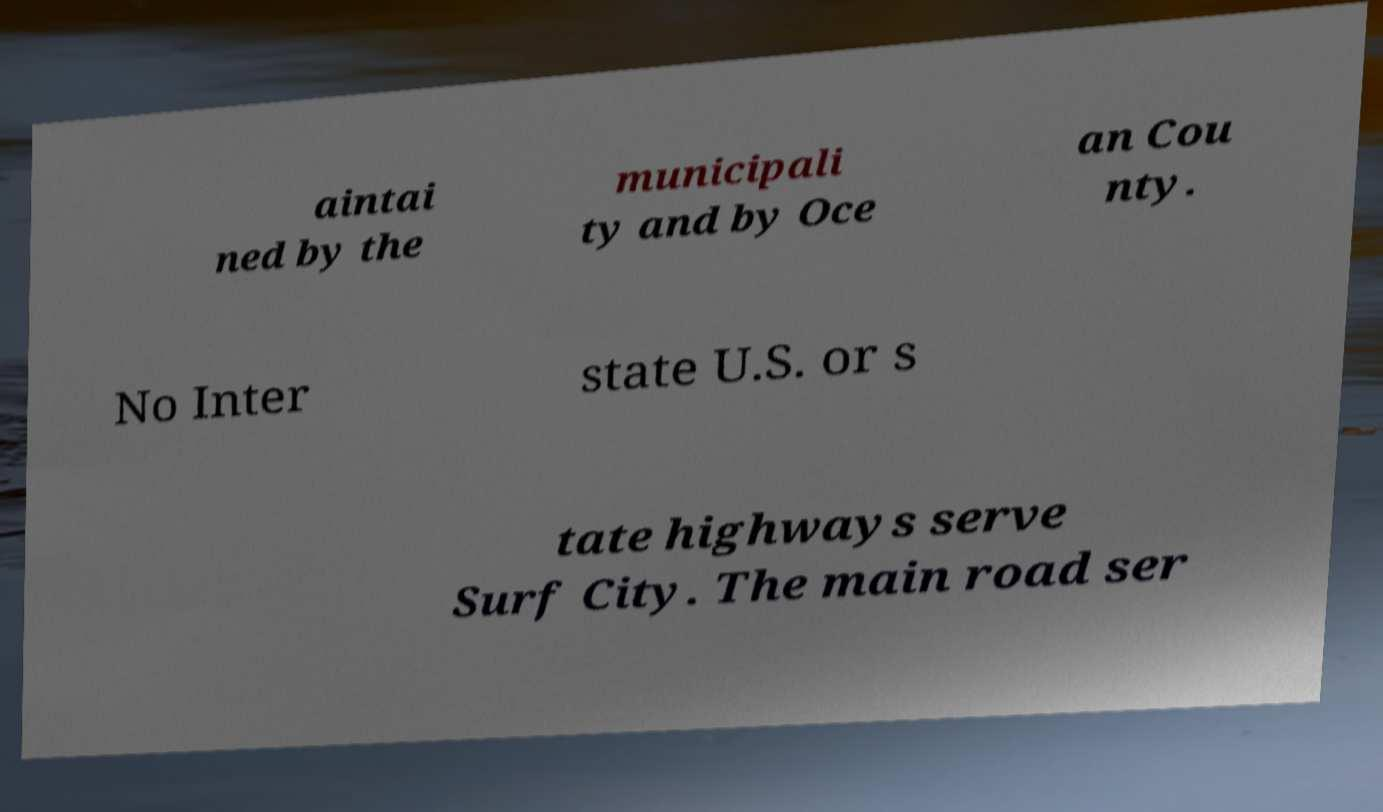I need the written content from this picture converted into text. Can you do that? aintai ned by the municipali ty and by Oce an Cou nty. No Inter state U.S. or s tate highways serve Surf City. The main road ser 